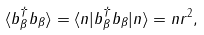Convert formula to latex. <formula><loc_0><loc_0><loc_500><loc_500>\langle b ^ { \dagger } _ { \beta } b _ { \beta } \rangle = \langle n | b ^ { \dagger } _ { \beta } b _ { \beta } | n \rangle = n r ^ { 2 } ,</formula> 